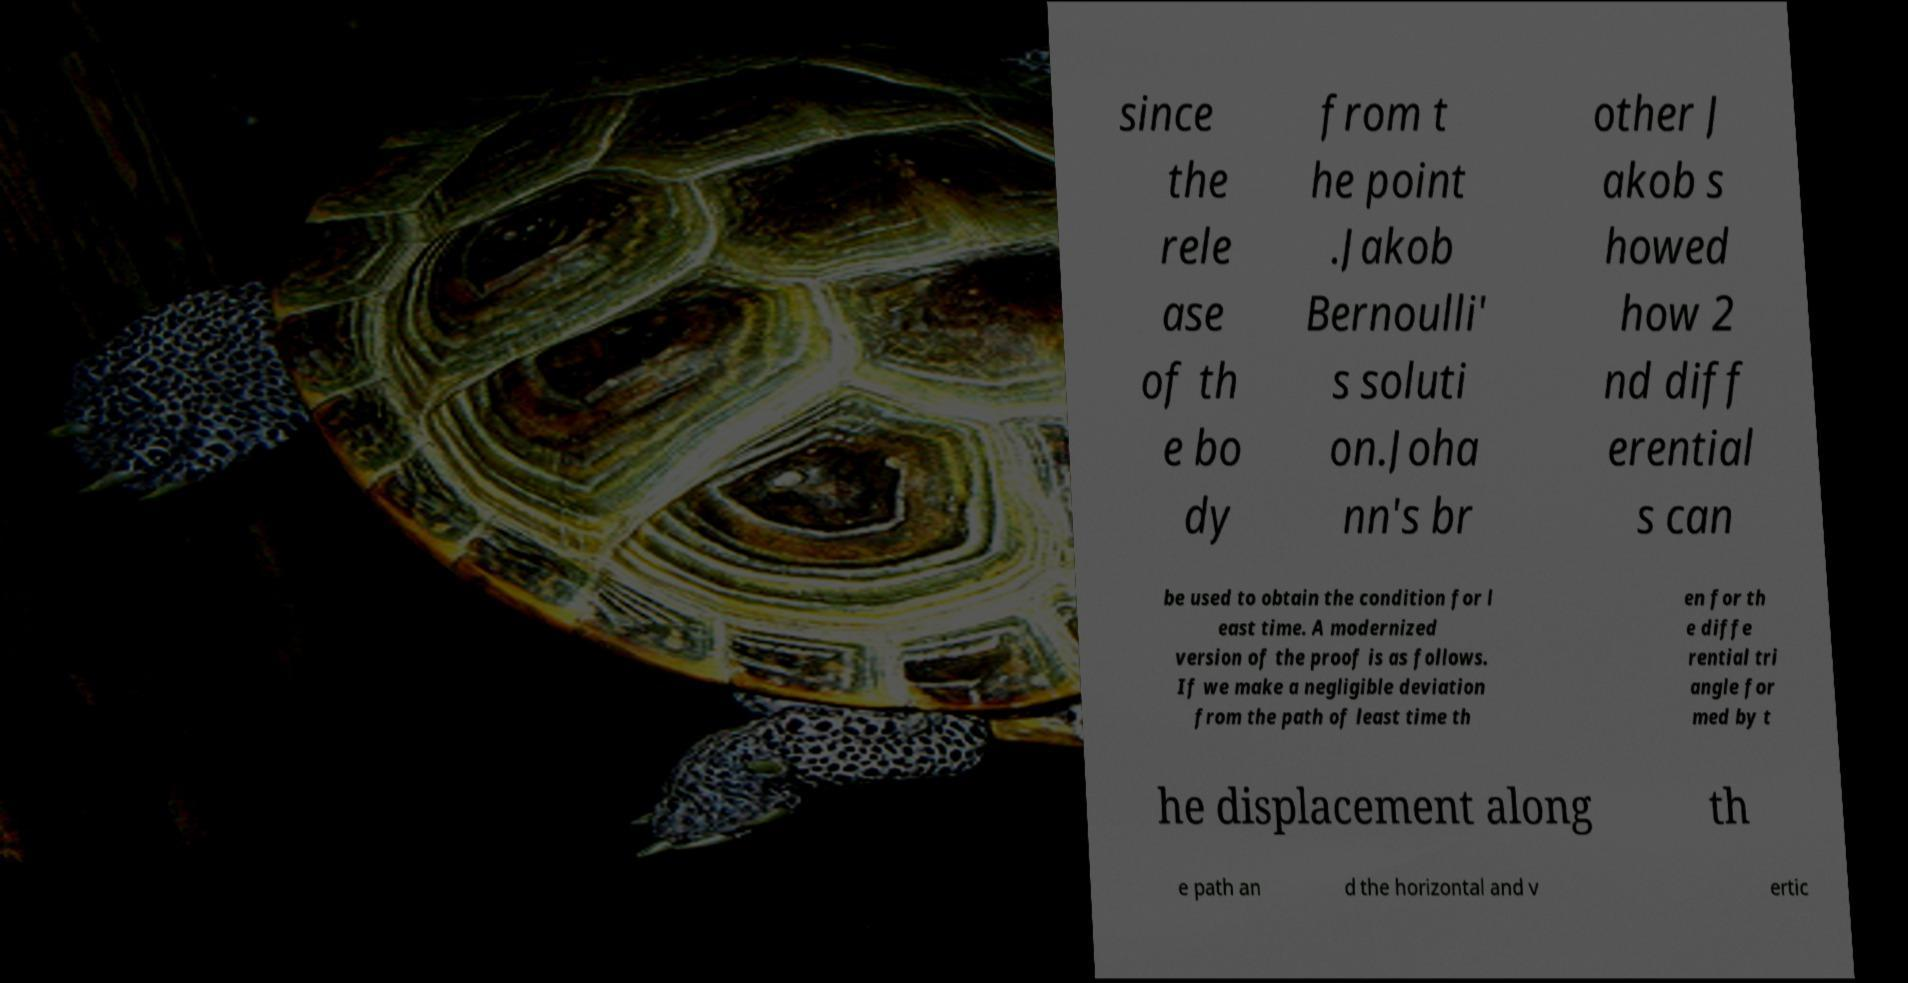Could you assist in decoding the text presented in this image and type it out clearly? since the rele ase of th e bo dy from t he point .Jakob Bernoulli' s soluti on.Joha nn's br other J akob s howed how 2 nd diff erential s can be used to obtain the condition for l east time. A modernized version of the proof is as follows. If we make a negligible deviation from the path of least time th en for th e diffe rential tri angle for med by t he displacement along th e path an d the horizontal and v ertic 